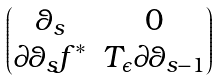Convert formula to latex. <formula><loc_0><loc_0><loc_500><loc_500>\begin{pmatrix} \theta _ { s } & 0 \\ \partial \theta _ { s } f ^ { * } & T _ { \epsilon } \partial \theta _ { s - 1 } \end{pmatrix}</formula> 